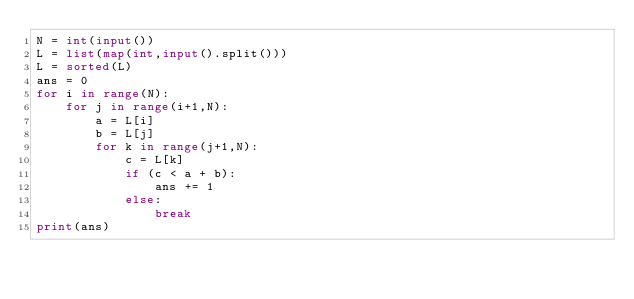<code> <loc_0><loc_0><loc_500><loc_500><_Python_>N = int(input())
L = list(map(int,input().split()))
L = sorted(L)
ans = 0
for i in range(N):
    for j in range(i+1,N):
        a = L[i]
        b = L[j]
        for k in range(j+1,N):
            c = L[k]
            if (c < a + b):
                ans += 1
            else:
                break
print(ans)
</code> 